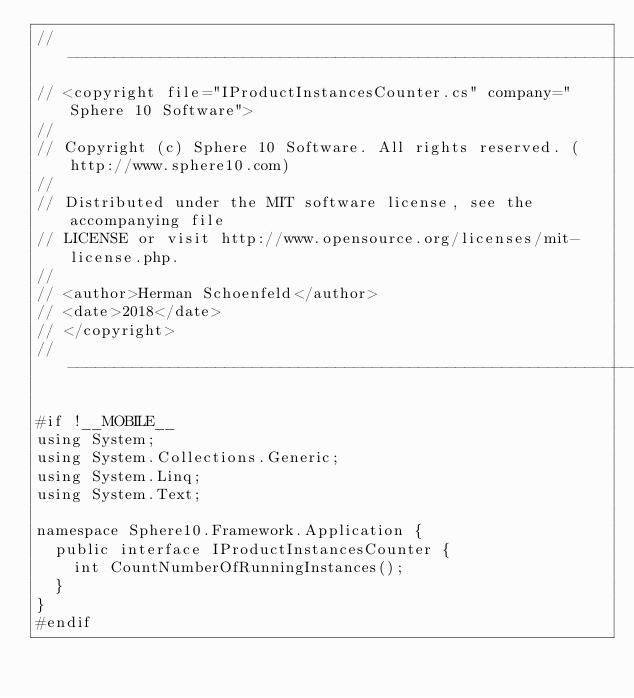<code> <loc_0><loc_0><loc_500><loc_500><_C#_>//-----------------------------------------------------------------------
// <copyright file="IProductInstancesCounter.cs" company="Sphere 10 Software">
//
// Copyright (c) Sphere 10 Software. All rights reserved. (http://www.sphere10.com)
//
// Distributed under the MIT software license, see the accompanying file
// LICENSE or visit http://www.opensource.org/licenses/mit-license.php.
//
// <author>Herman Schoenfeld</author>
// <date>2018</date>
// </copyright>
//-----------------------------------------------------------------------

#if !__MOBILE__
using System;
using System.Collections.Generic;
using System.Linq;
using System.Text;

namespace Sphere10.Framework.Application {
	public interface IProductInstancesCounter {
		int CountNumberOfRunningInstances();
	}
}
#endif
</code> 